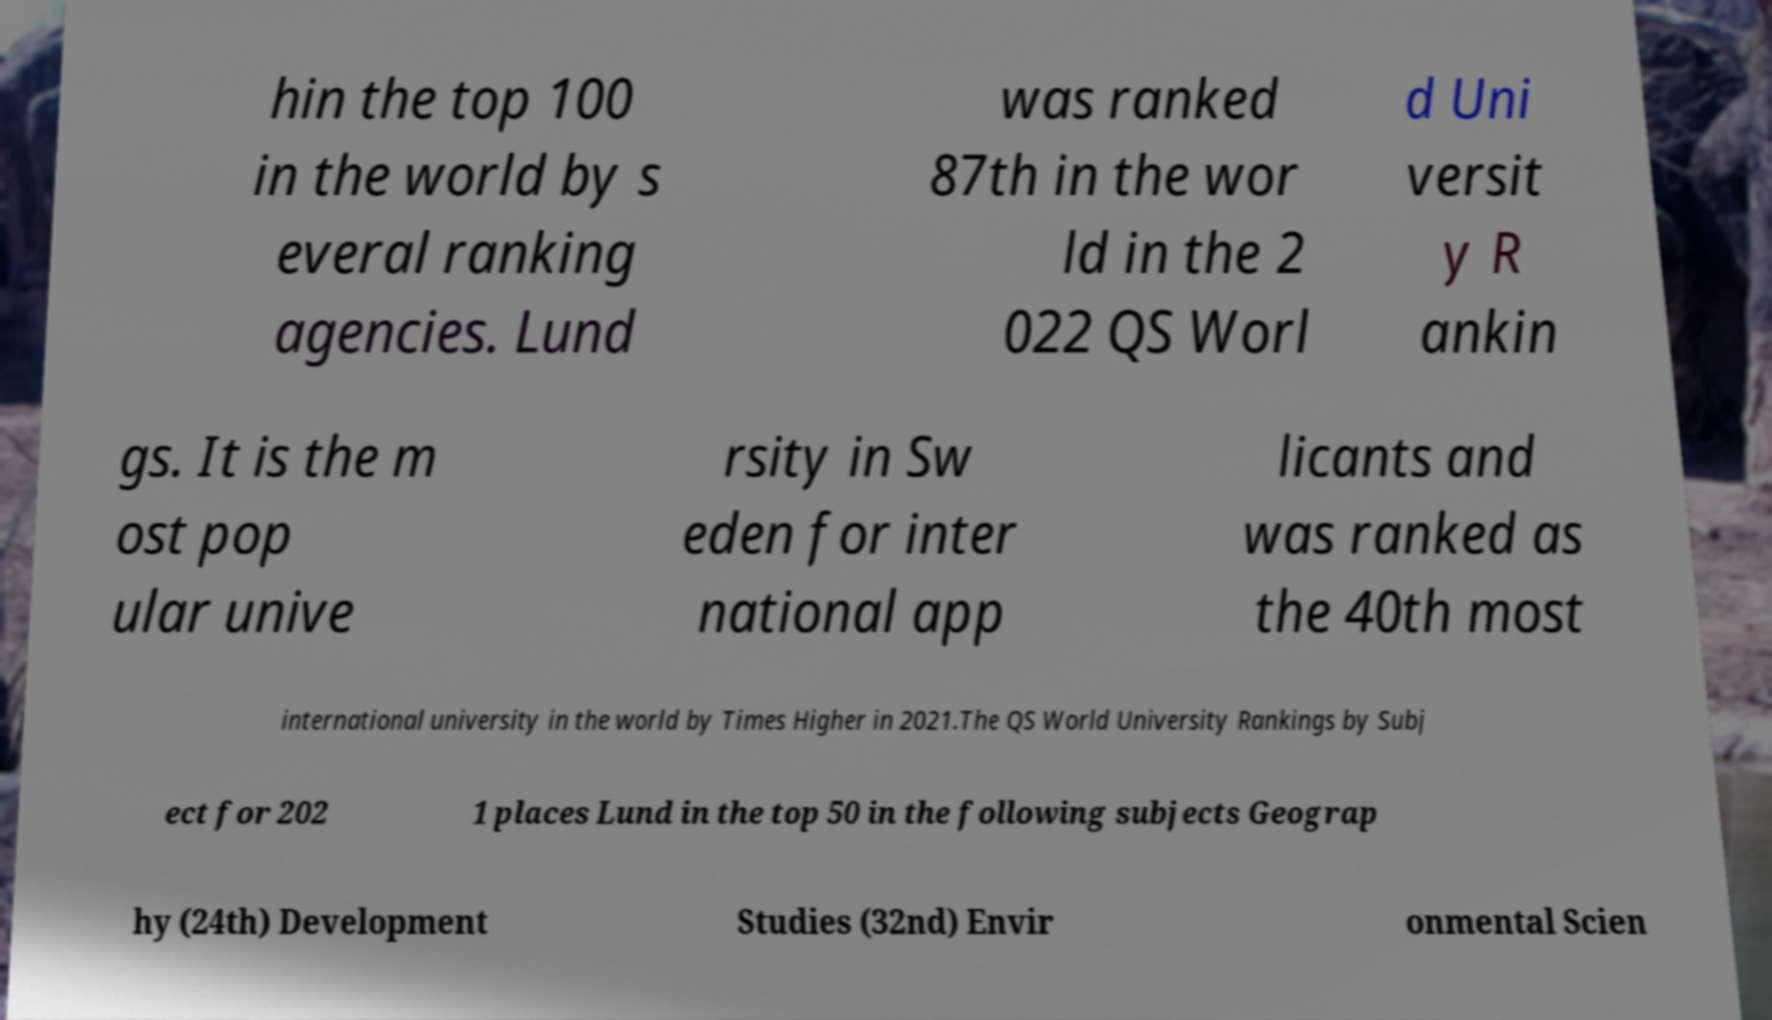Please identify and transcribe the text found in this image. hin the top 100 in the world by s everal ranking agencies. Lund was ranked 87th in the wor ld in the 2 022 QS Worl d Uni versit y R ankin gs. It is the m ost pop ular unive rsity in Sw eden for inter national app licants and was ranked as the 40th most international university in the world by Times Higher in 2021.The QS World University Rankings by Subj ect for 202 1 places Lund in the top 50 in the following subjects Geograp hy (24th) Development Studies (32nd) Envir onmental Scien 